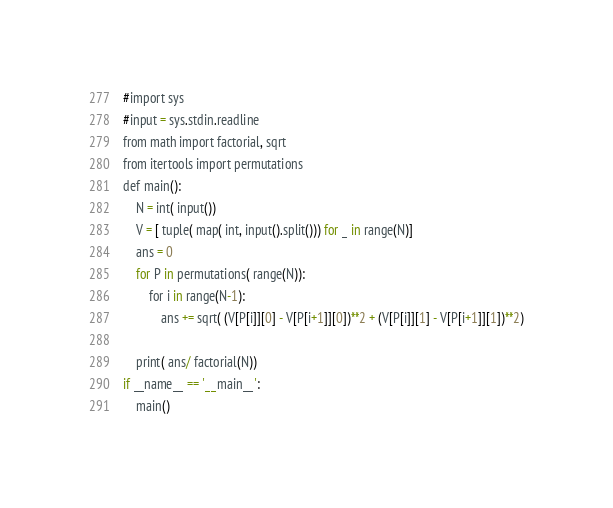Convert code to text. <code><loc_0><loc_0><loc_500><loc_500><_Rust_>#import sys
#input = sys.stdin.readline
from math import factorial, sqrt
from itertools import permutations
def main():
    N = int( input())
    V = [ tuple( map( int, input().split())) for _ in range(N)]
    ans = 0
    for P in permutations( range(N)):
        for i in range(N-1):
            ans += sqrt( (V[P[i]][0] - V[P[i+1]][0])**2 + (V[P[i]][1] - V[P[i+1]][1])**2)

    print( ans/ factorial(N))
if __name__ == '__main__':
    main()
</code> 